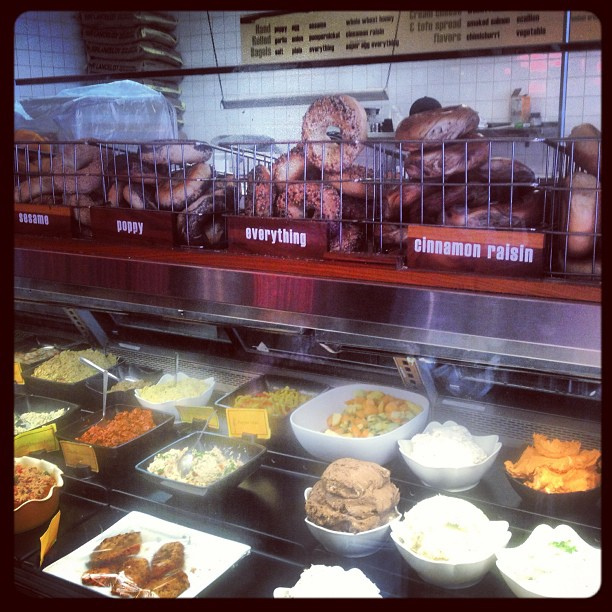Identify the text contained in this image. poppy everything cinnamon raisin 